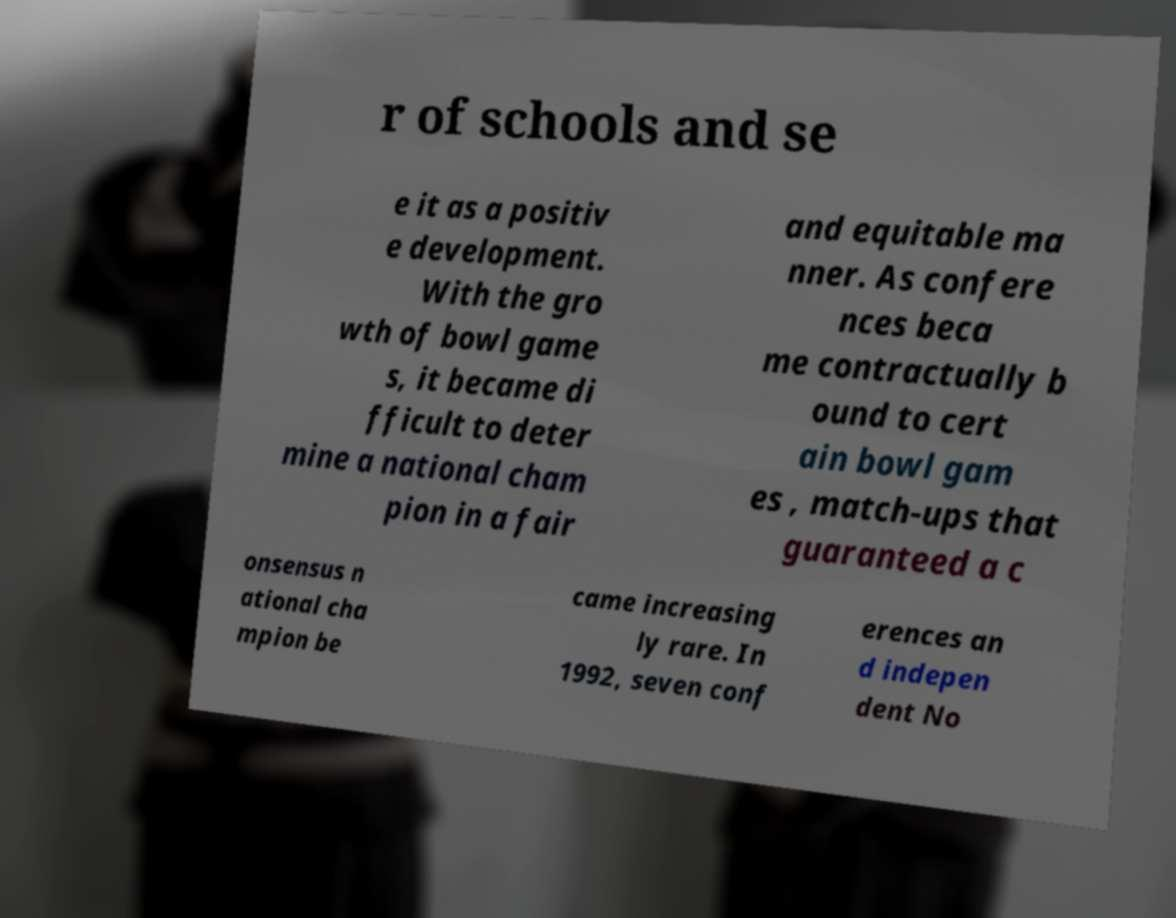Could you assist in decoding the text presented in this image and type it out clearly? r of schools and se e it as a positiv e development. With the gro wth of bowl game s, it became di fficult to deter mine a national cham pion in a fair and equitable ma nner. As confere nces beca me contractually b ound to cert ain bowl gam es , match-ups that guaranteed a c onsensus n ational cha mpion be came increasing ly rare. In 1992, seven conf erences an d indepen dent No 